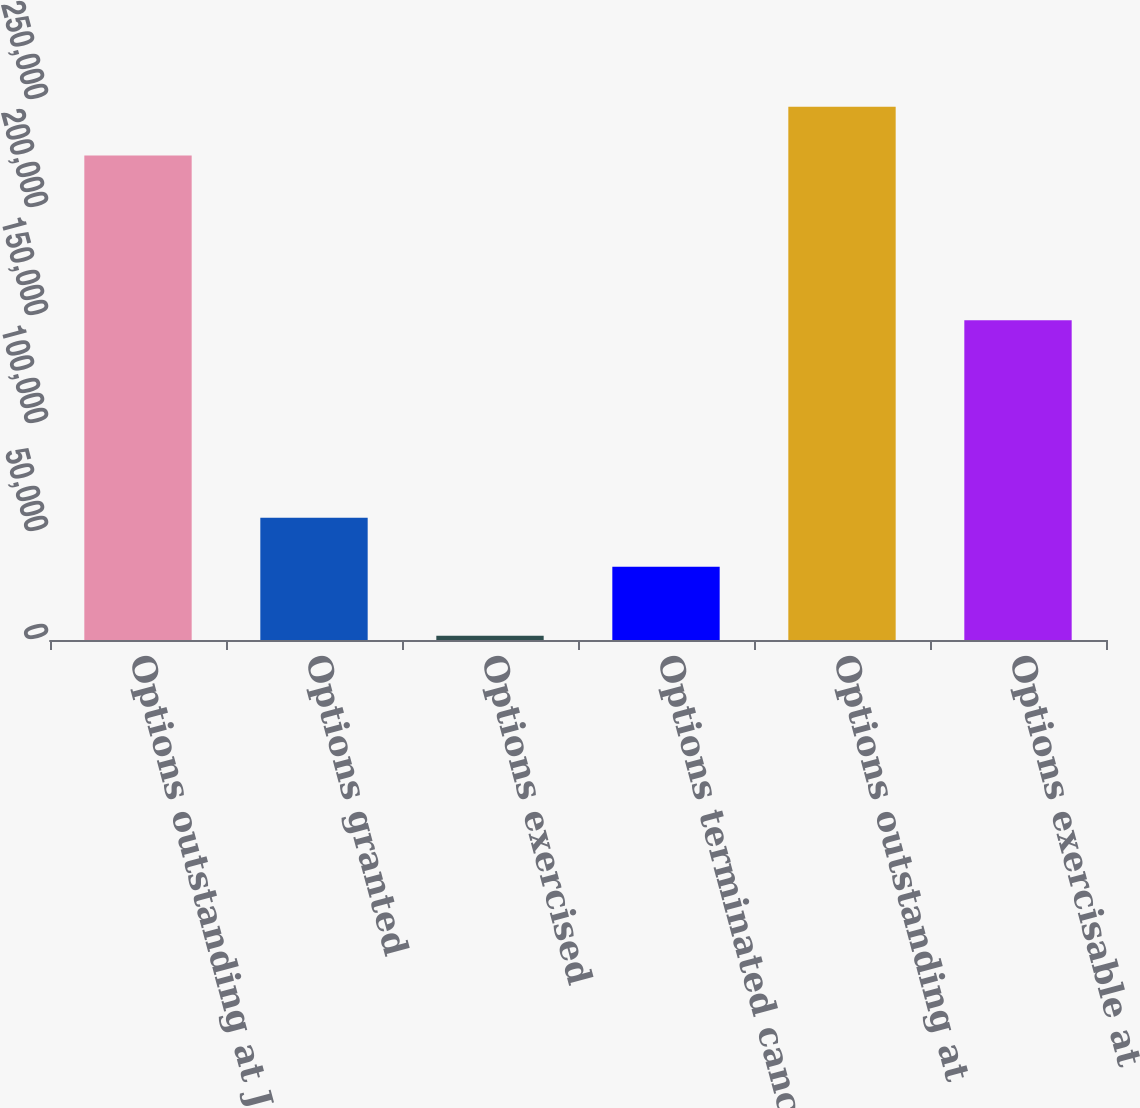Convert chart. <chart><loc_0><loc_0><loc_500><loc_500><bar_chart><fcel>Options outstanding at January<fcel>Options granted<fcel>Options exercised<fcel>Options terminated canceled or<fcel>Options outstanding at<fcel>Options exercisable at<nl><fcel>224255<fcel>56576.5<fcel>1920<fcel>33954<fcel>246878<fcel>148072<nl></chart> 